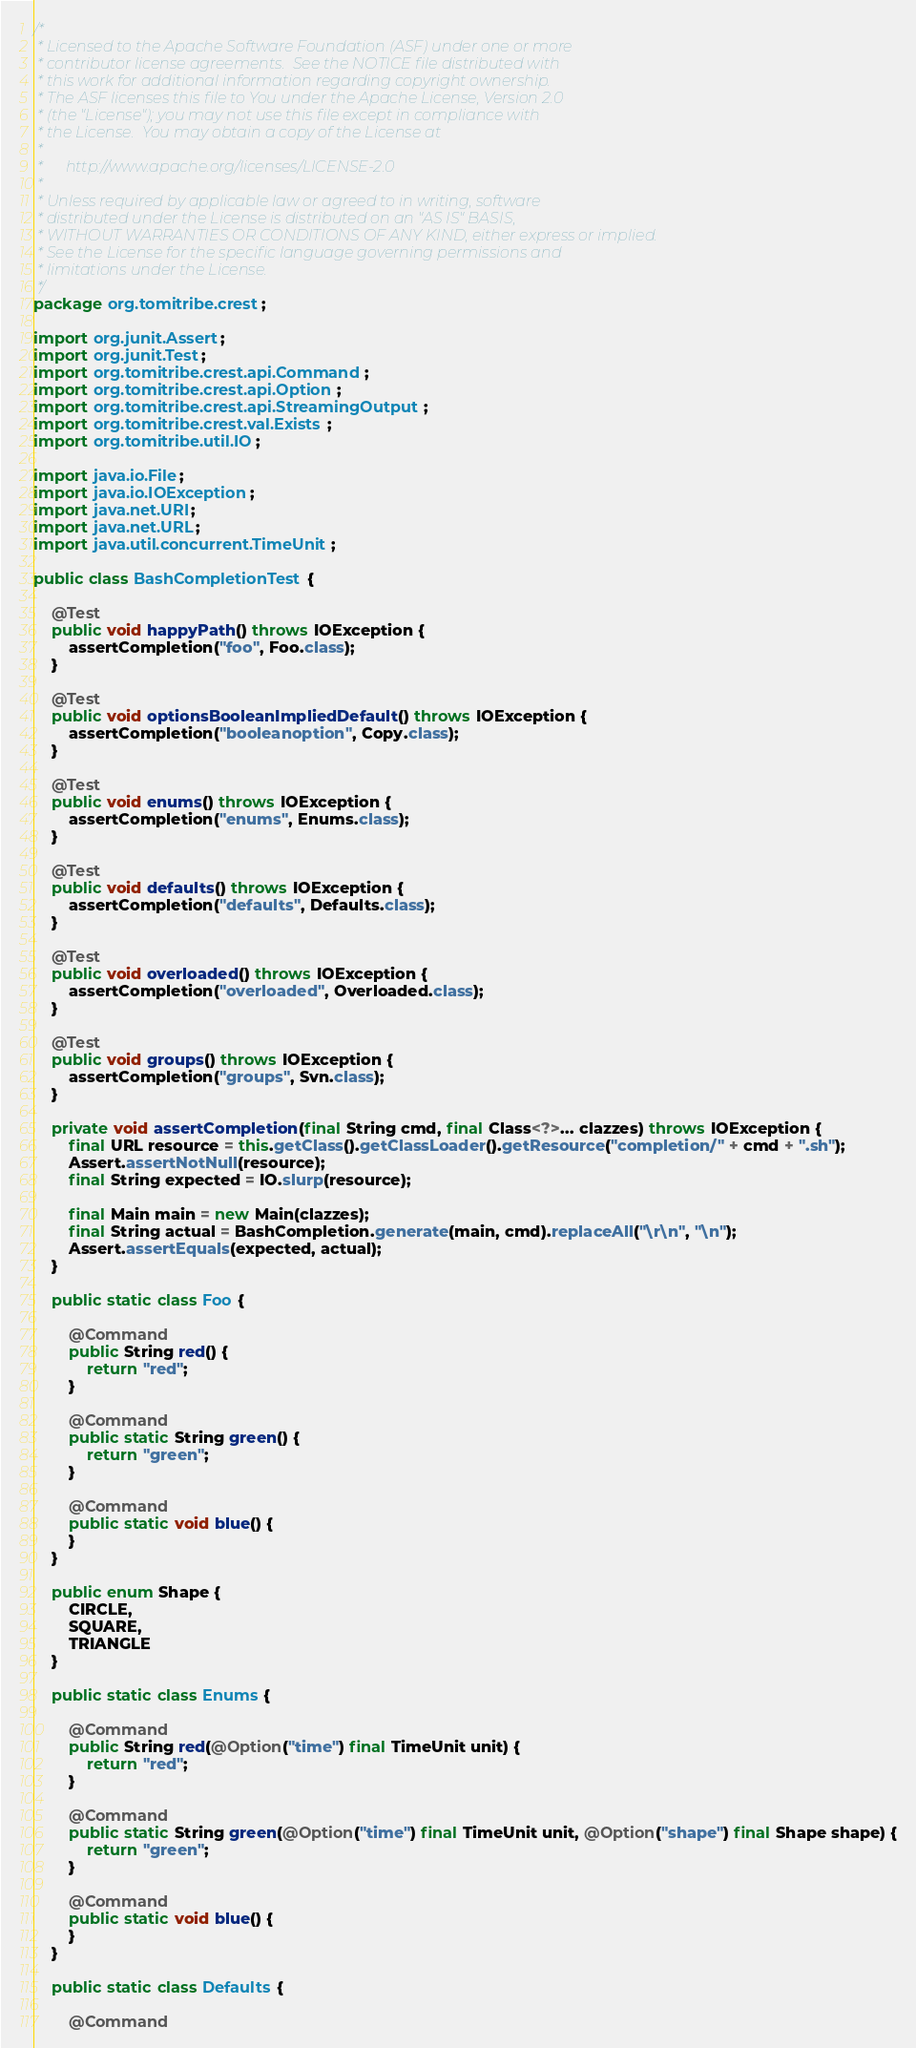<code> <loc_0><loc_0><loc_500><loc_500><_Java_>/*
 * Licensed to the Apache Software Foundation (ASF) under one or more
 * contributor license agreements.  See the NOTICE file distributed with
 * this work for additional information regarding copyright ownership.
 * The ASF licenses this file to You under the Apache License, Version 2.0
 * (the "License"); you may not use this file except in compliance with
 * the License.  You may obtain a copy of the License at
 *
 *      http://www.apache.org/licenses/LICENSE-2.0
 *
 * Unless required by applicable law or agreed to in writing, software
 * distributed under the License is distributed on an "AS IS" BASIS,
 * WITHOUT WARRANTIES OR CONDITIONS OF ANY KIND, either express or implied.
 * See the License for the specific language governing permissions and
 * limitations under the License.
 */
package org.tomitribe.crest;

import org.junit.Assert;
import org.junit.Test;
import org.tomitribe.crest.api.Command;
import org.tomitribe.crest.api.Option;
import org.tomitribe.crest.api.StreamingOutput;
import org.tomitribe.crest.val.Exists;
import org.tomitribe.util.IO;

import java.io.File;
import java.io.IOException;
import java.net.URI;
import java.net.URL;
import java.util.concurrent.TimeUnit;

public class BashCompletionTest {

    @Test
    public void happyPath() throws IOException {
        assertCompletion("foo", Foo.class);
    }

    @Test
    public void optionsBooleanImpliedDefault() throws IOException {
        assertCompletion("booleanoption", Copy.class);
    }

    @Test
    public void enums() throws IOException {
        assertCompletion("enums", Enums.class);
    }

    @Test
    public void defaults() throws IOException {
        assertCompletion("defaults", Defaults.class);
    }

    @Test
    public void overloaded() throws IOException {
        assertCompletion("overloaded", Overloaded.class);
    }

    @Test
    public void groups() throws IOException {
        assertCompletion("groups", Svn.class);
    }

    private void assertCompletion(final String cmd, final Class<?>... clazzes) throws IOException {
        final URL resource = this.getClass().getClassLoader().getResource("completion/" + cmd + ".sh");
        Assert.assertNotNull(resource);
        final String expected = IO.slurp(resource);

        final Main main = new Main(clazzes);
        final String actual = BashCompletion.generate(main, cmd).replaceAll("\r\n", "\n");
        Assert.assertEquals(expected, actual);
    }

    public static class Foo {

        @Command
        public String red() {
            return "red";
        }

        @Command
        public static String green() {
            return "green";
        }

        @Command
        public static void blue() {
        }
    }

    public enum Shape {
        CIRCLE,
        SQUARE,
        TRIANGLE
    }

    public static class Enums {

        @Command
        public String red(@Option("time") final TimeUnit unit) {
            return "red";
        }

        @Command
        public static String green(@Option("time") final TimeUnit unit, @Option("shape") final Shape shape) {
            return "green";
        }

        @Command
        public static void blue() {
        }
    }

    public static class Defaults {

        @Command</code> 